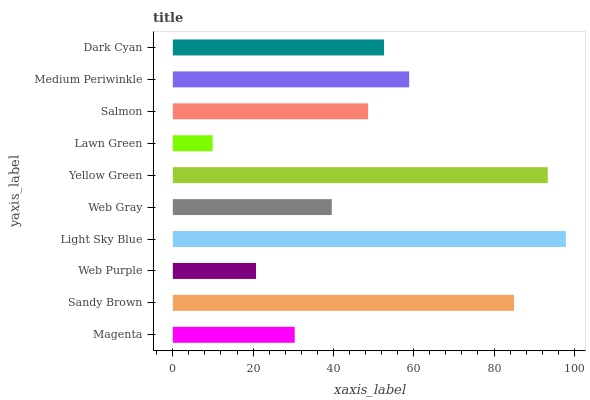Is Lawn Green the minimum?
Answer yes or no. Yes. Is Light Sky Blue the maximum?
Answer yes or no. Yes. Is Sandy Brown the minimum?
Answer yes or no. No. Is Sandy Brown the maximum?
Answer yes or no. No. Is Sandy Brown greater than Magenta?
Answer yes or no. Yes. Is Magenta less than Sandy Brown?
Answer yes or no. Yes. Is Magenta greater than Sandy Brown?
Answer yes or no. No. Is Sandy Brown less than Magenta?
Answer yes or no. No. Is Dark Cyan the high median?
Answer yes or no. Yes. Is Salmon the low median?
Answer yes or no. Yes. Is Magenta the high median?
Answer yes or no. No. Is Sandy Brown the low median?
Answer yes or no. No. 